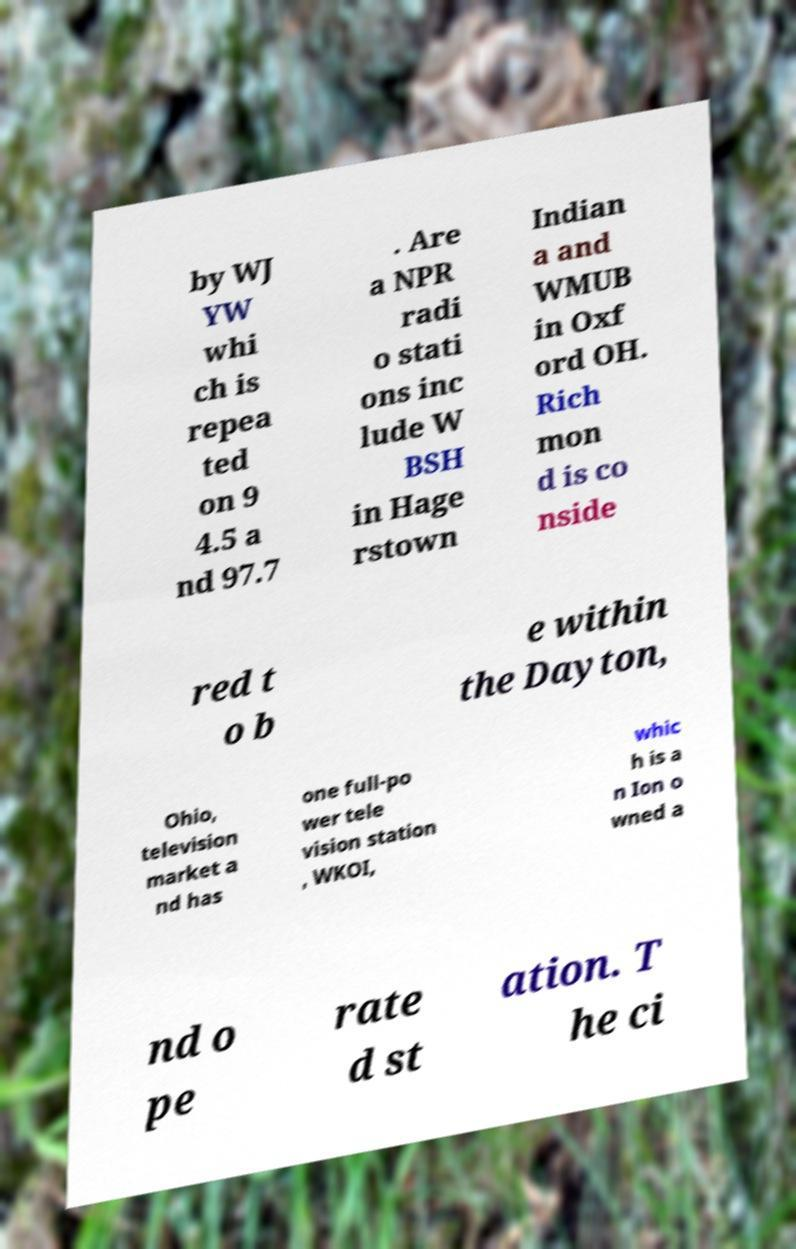Can you accurately transcribe the text from the provided image for me? by WJ YW whi ch is repea ted on 9 4.5 a nd 97.7 . Are a NPR radi o stati ons inc lude W BSH in Hage rstown Indian a and WMUB in Oxf ord OH. Rich mon d is co nside red t o b e within the Dayton, Ohio, television market a nd has one full-po wer tele vision station , WKOI, whic h is a n Ion o wned a nd o pe rate d st ation. T he ci 